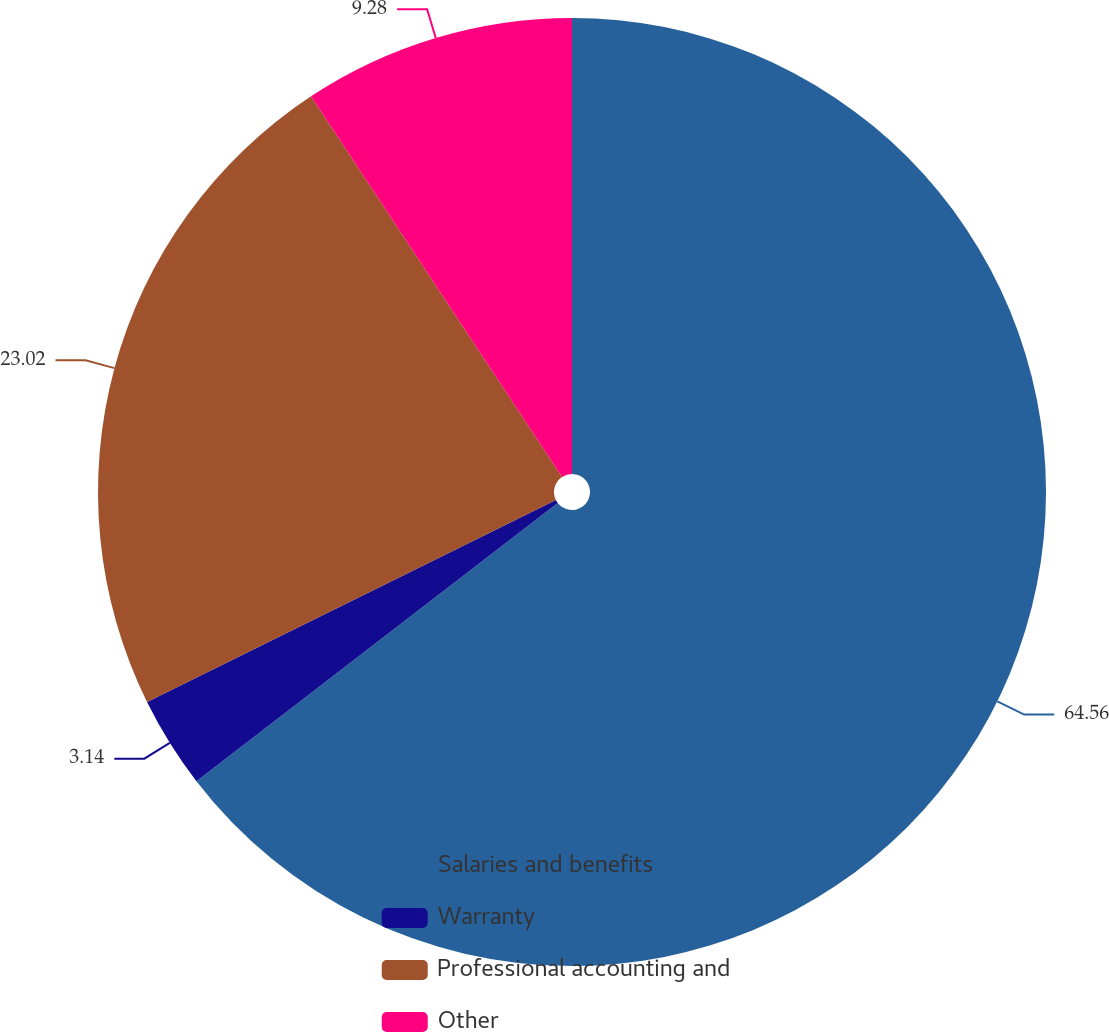Convert chart to OTSL. <chart><loc_0><loc_0><loc_500><loc_500><pie_chart><fcel>Salaries and benefits<fcel>Warranty<fcel>Professional accounting and<fcel>Other<nl><fcel>64.55%<fcel>3.14%<fcel>23.02%<fcel>9.28%<nl></chart> 